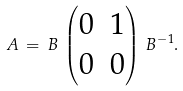<formula> <loc_0><loc_0><loc_500><loc_500>A \, = \, B \, \begin{pmatrix} 0 & 1 \\ 0 & 0 \end{pmatrix} \, B ^ { - 1 } .</formula> 